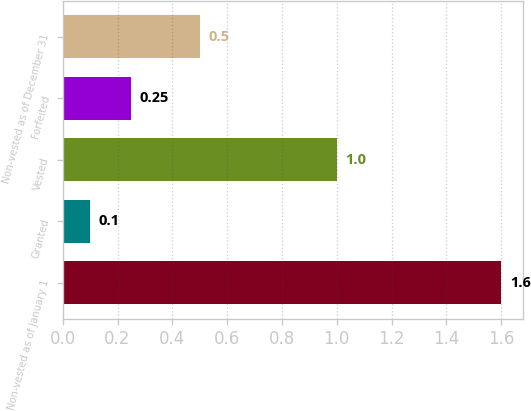Convert chart to OTSL. <chart><loc_0><loc_0><loc_500><loc_500><bar_chart><fcel>Non-vested as of January 1<fcel>Granted<fcel>Vested<fcel>Forfeited<fcel>Non-vested as of December 31<nl><fcel>1.6<fcel>0.1<fcel>1<fcel>0.25<fcel>0.5<nl></chart> 